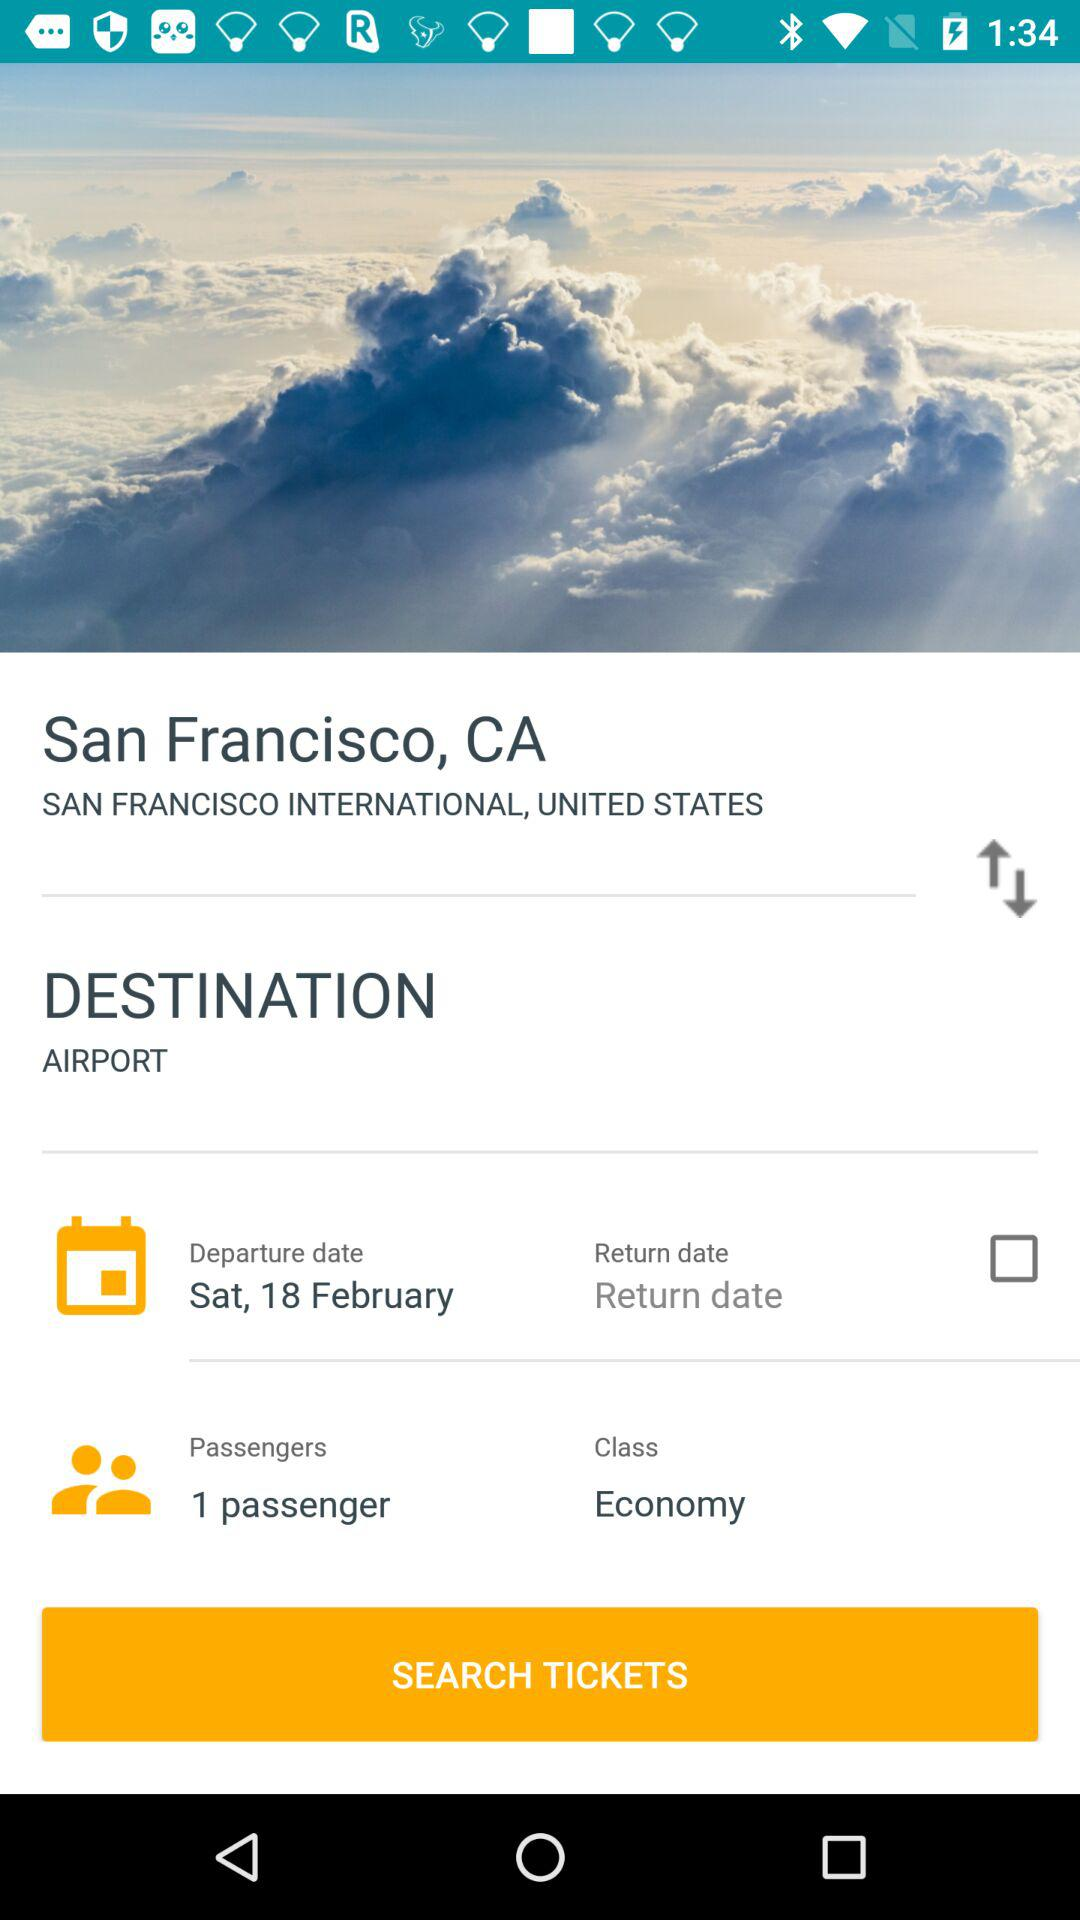When is the return date?
When the provided information is insufficient, respond with <no answer>. <no answer> 